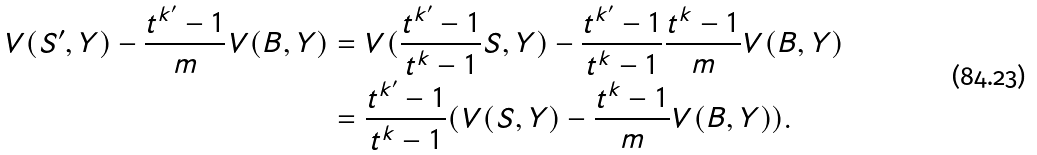Convert formula to latex. <formula><loc_0><loc_0><loc_500><loc_500>V ( S ^ { \prime } , Y ) - \frac { t ^ { k ^ { \prime } } - 1 } { m } V ( B , Y ) & = V ( \frac { t ^ { k ^ { \prime } } - 1 } { t ^ { k } - 1 } S , Y ) - \frac { t ^ { k ^ { \prime } } - 1 } { t ^ { k } - 1 } \frac { t ^ { k } - 1 } { m } V ( B , Y ) \\ & = \frac { t ^ { k ^ { \prime } } - 1 } { t ^ { k } - 1 } ( V ( S , Y ) - \frac { t ^ { k } - 1 } { m } V ( B , Y ) ) .</formula> 